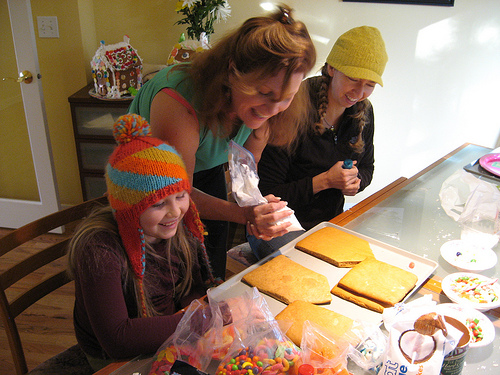<image>
Is there a hat to the left of the girl? Yes. From this viewpoint, the hat is positioned to the left side relative to the girl. 